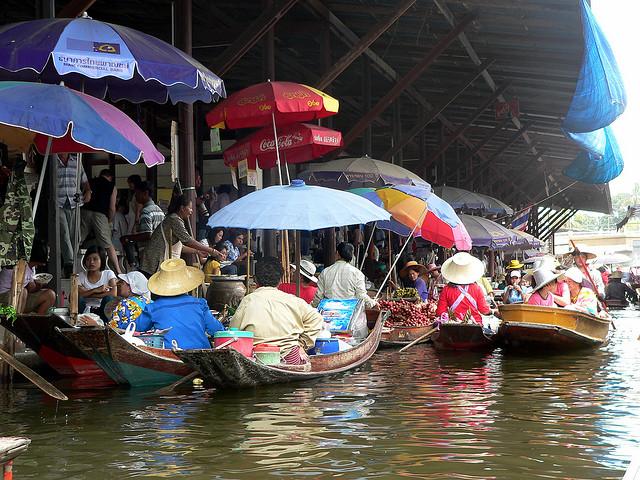What color is the water?
Keep it brief. Brown. Is the water calm?
Quick response, please. Yes. How many umbrellas are in this picture?
Concise answer only. 9. 